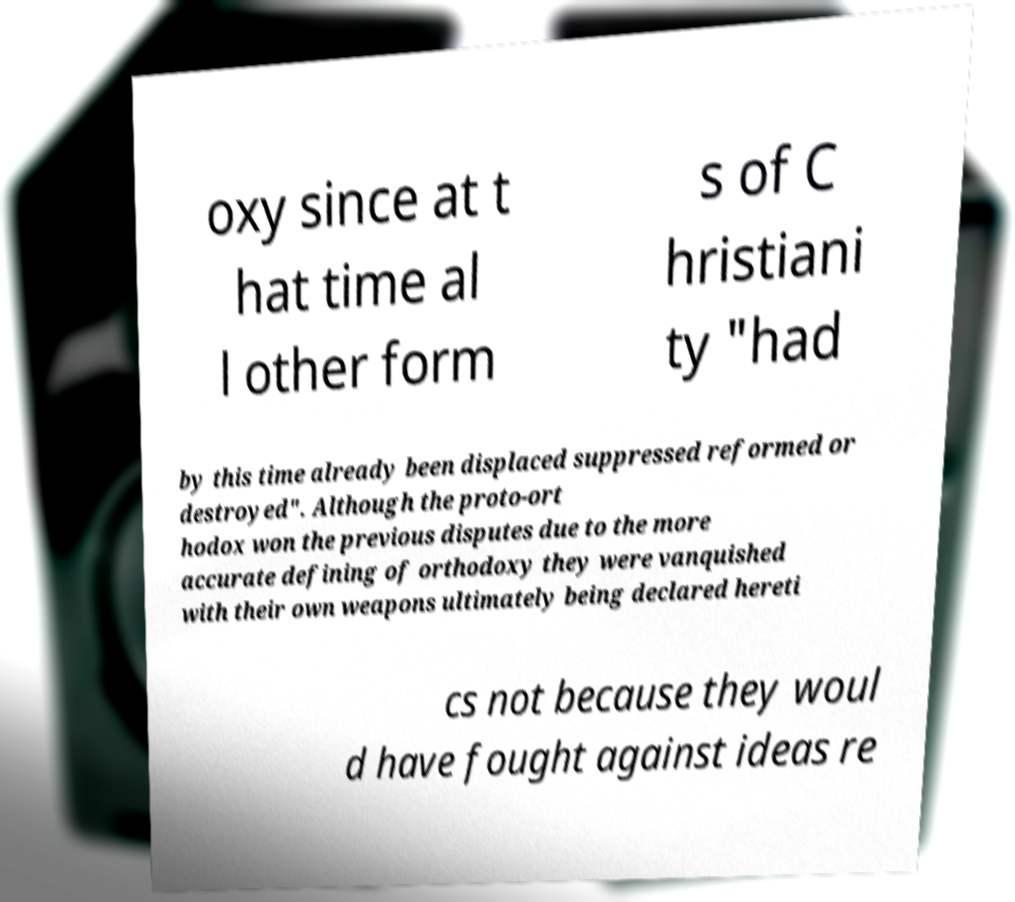Could you assist in decoding the text presented in this image and type it out clearly? oxy since at t hat time al l other form s of C hristiani ty "had by this time already been displaced suppressed reformed or destroyed". Although the proto-ort hodox won the previous disputes due to the more accurate defining of orthodoxy they were vanquished with their own weapons ultimately being declared hereti cs not because they woul d have fought against ideas re 